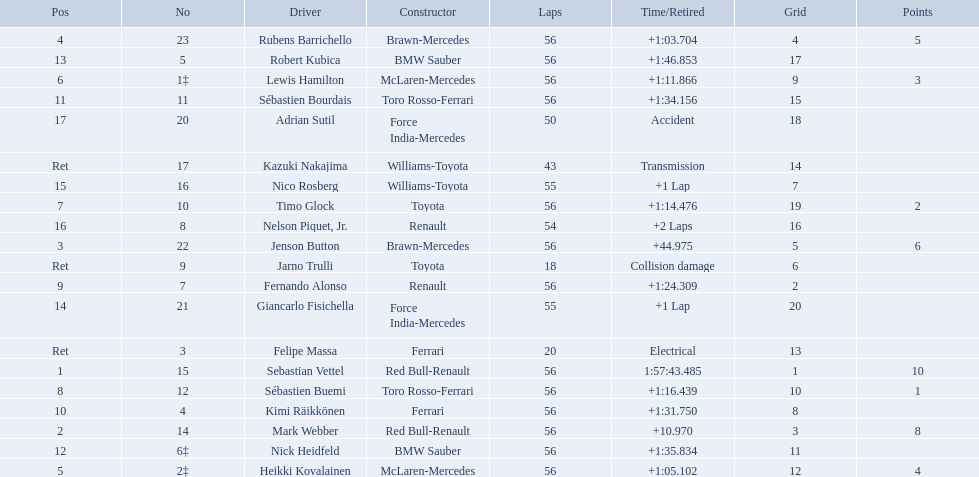Who were all of the drivers in the 2009 chinese grand prix? Sebastian Vettel, Mark Webber, Jenson Button, Rubens Barrichello, Heikki Kovalainen, Lewis Hamilton, Timo Glock, Sébastien Buemi, Fernando Alonso, Kimi Räikkönen, Sébastien Bourdais, Nick Heidfeld, Robert Kubica, Giancarlo Fisichella, Nico Rosberg, Nelson Piquet, Jr., Adrian Sutil, Kazuki Nakajima, Felipe Massa, Jarno Trulli. And what were their finishing times? 1:57:43.485, +10.970, +44.975, +1:03.704, +1:05.102, +1:11.866, +1:14.476, +1:16.439, +1:24.309, +1:31.750, +1:34.156, +1:35.834, +1:46.853, +1 Lap, +1 Lap, +2 Laps, Accident, Transmission, Electrical, Collision damage. Which player faced collision damage and retired from the race? Jarno Trulli. Which drivers raced in the 2009 chinese grand prix? Sebastian Vettel, Mark Webber, Jenson Button, Rubens Barrichello, Heikki Kovalainen, Lewis Hamilton, Timo Glock, Sébastien Buemi, Fernando Alonso, Kimi Räikkönen, Sébastien Bourdais, Nick Heidfeld, Robert Kubica, Giancarlo Fisichella, Nico Rosberg, Nelson Piquet, Jr., Adrian Sutil, Kazuki Nakajima, Felipe Massa, Jarno Trulli. Of the drivers in the 2009 chinese grand prix, which finished the race? Sebastian Vettel, Mark Webber, Jenson Button, Rubens Barrichello, Heikki Kovalainen, Lewis Hamilton, Timo Glock, Sébastien Buemi, Fernando Alonso, Kimi Räikkönen, Sébastien Bourdais, Nick Heidfeld, Robert Kubica. Of the drivers who finished the race, who had the slowest time? Robert Kubica. Which drive retired because of electrical issues? Felipe Massa. Which driver retired due to accident? Adrian Sutil. Which driver retired due to collision damage? Jarno Trulli. 